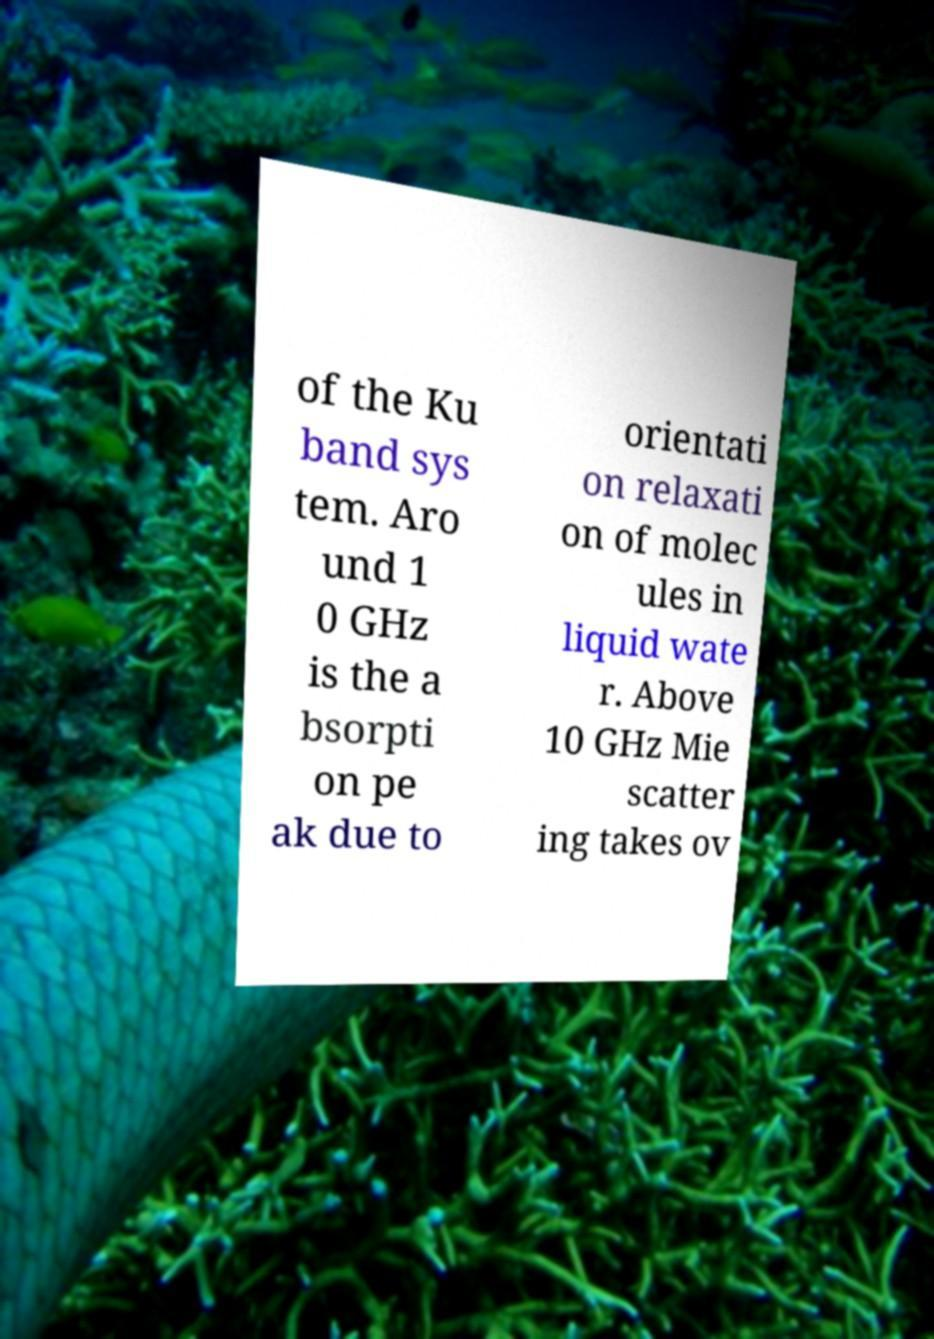Could you extract and type out the text from this image? of the Ku band sys tem. Aro und 1 0 GHz is the a bsorpti on pe ak due to orientati on relaxati on of molec ules in liquid wate r. Above 10 GHz Mie scatter ing takes ov 